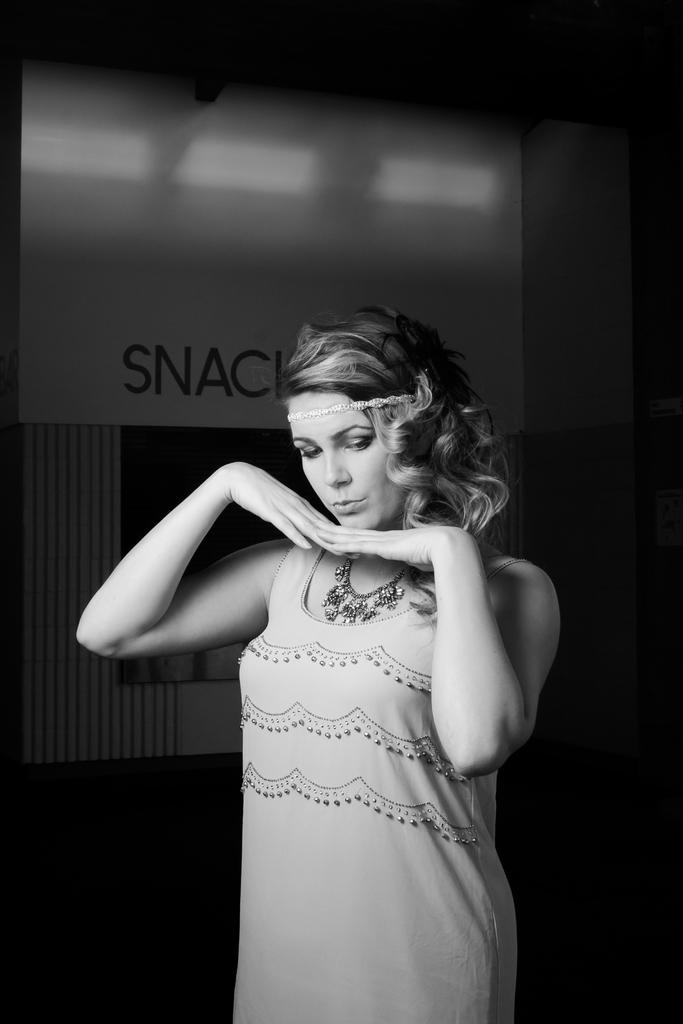What is the main subject in the foreground of the image? There is a woman standing in the foreground of the image. What can be seen in the background of the image? There is a screen and a wall in the background of the image. What type of amusement can be seen on the screen in the image? There is no amusement visible on the screen in the image; it is not mentioned in the provided facts. 